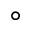Convert formula to latex. <formula><loc_0><loc_0><loc_500><loc_500>^ { \circ }</formula> 